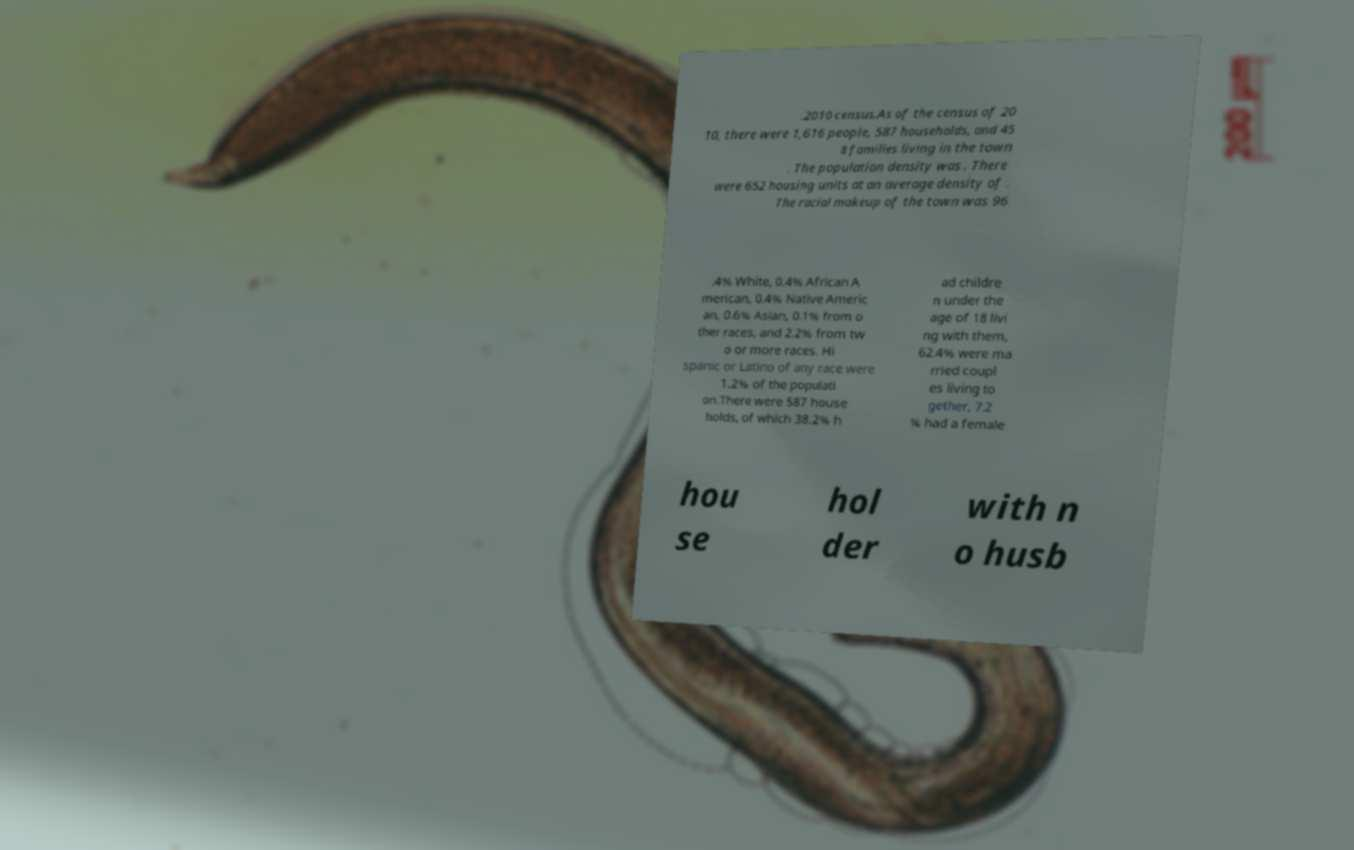Could you assist in decoding the text presented in this image and type it out clearly? .2010 census.As of the census of 20 10, there were 1,616 people, 587 households, and 45 8 families living in the town . The population density was . There were 652 housing units at an average density of . The racial makeup of the town was 96 .4% White, 0.4% African A merican, 0.4% Native Americ an, 0.6% Asian, 0.1% from o ther races, and 2.2% from tw o or more races. Hi spanic or Latino of any race were 1.2% of the populati on.There were 587 house holds, of which 38.2% h ad childre n under the age of 18 livi ng with them, 62.4% were ma rried coupl es living to gether, 7.2 % had a female hou se hol der with n o husb 